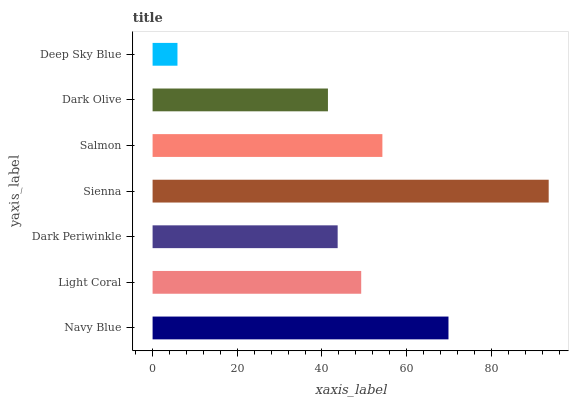Is Deep Sky Blue the minimum?
Answer yes or no. Yes. Is Sienna the maximum?
Answer yes or no. Yes. Is Light Coral the minimum?
Answer yes or no. No. Is Light Coral the maximum?
Answer yes or no. No. Is Navy Blue greater than Light Coral?
Answer yes or no. Yes. Is Light Coral less than Navy Blue?
Answer yes or no. Yes. Is Light Coral greater than Navy Blue?
Answer yes or no. No. Is Navy Blue less than Light Coral?
Answer yes or no. No. Is Light Coral the high median?
Answer yes or no. Yes. Is Light Coral the low median?
Answer yes or no. Yes. Is Deep Sky Blue the high median?
Answer yes or no. No. Is Sienna the low median?
Answer yes or no. No. 